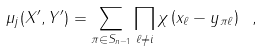<formula> <loc_0><loc_0><loc_500><loc_500>\mu _ { j } ( X ^ { \prime } , Y ^ { \prime } ) = \sum _ { \pi \in S _ { n - 1 } } \prod _ { \ell \neq i } \chi \left ( x _ { \ell } - y _ { \pi \ell } \right ) \ ,</formula> 